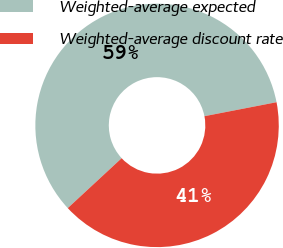<chart> <loc_0><loc_0><loc_500><loc_500><pie_chart><fcel>Weighted-average expected<fcel>Weighted-average discount rate<nl><fcel>58.84%<fcel>41.16%<nl></chart> 